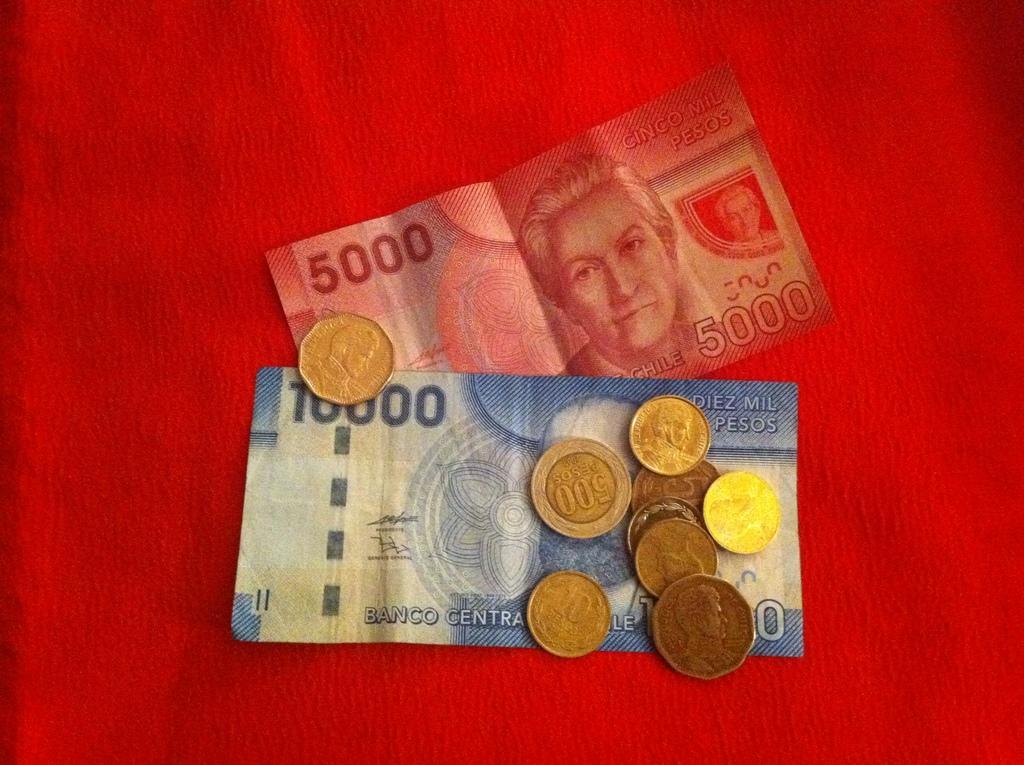Please provide a concise description of this image. In this picture, we see five thousand currency note and ten thousand currency note. We even see currency coins. In the background, it is red in color. 